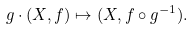Convert formula to latex. <formula><loc_0><loc_0><loc_500><loc_500>g \cdot ( X , f ) \mapsto ( X , f \circ g ^ { - 1 } ) .</formula> 